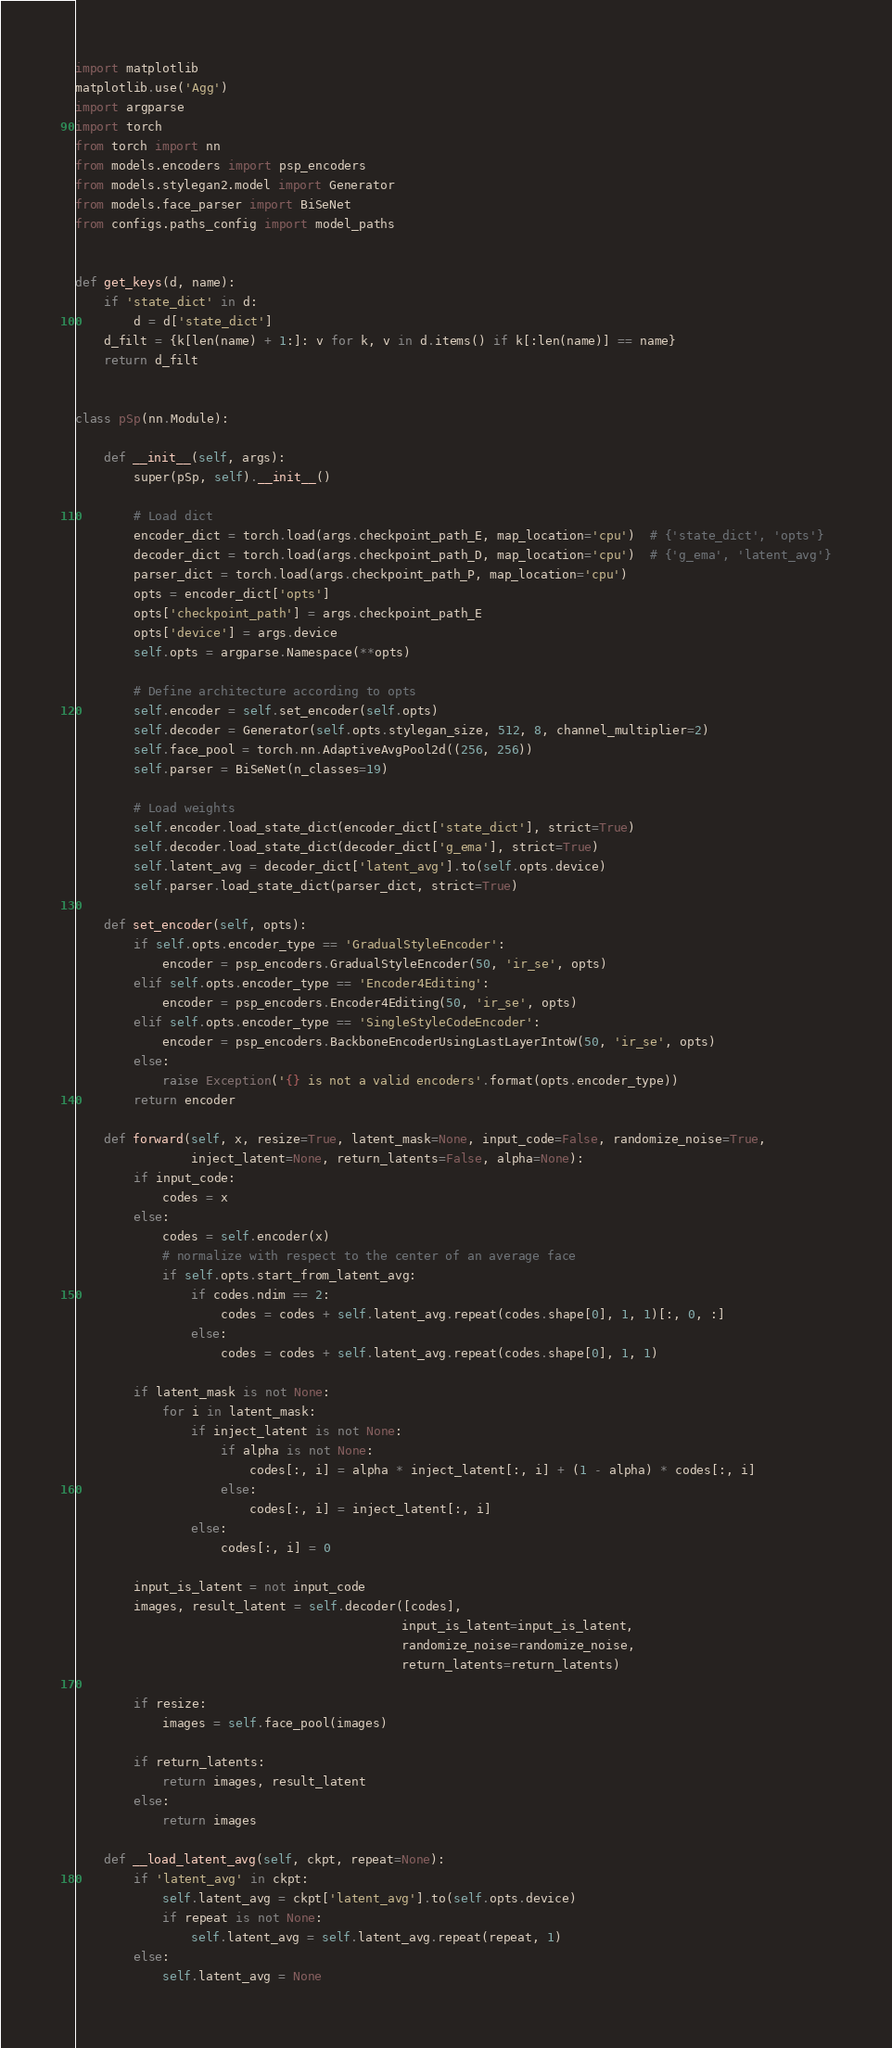<code> <loc_0><loc_0><loc_500><loc_500><_Python_>import matplotlib
matplotlib.use('Agg')
import argparse
import torch
from torch import nn
from models.encoders import psp_encoders
from models.stylegan2.model import Generator
from models.face_parser import BiSeNet
from configs.paths_config import model_paths


def get_keys(d, name):
    if 'state_dict' in d:
        d = d['state_dict']
    d_filt = {k[len(name) + 1:]: v for k, v in d.items() if k[:len(name)] == name}
    return d_filt


class pSp(nn.Module):

    def __init__(self, args):
        super(pSp, self).__init__()

        # Load dict
        encoder_dict = torch.load(args.checkpoint_path_E, map_location='cpu')  # {'state_dict', 'opts'}
        decoder_dict = torch.load(args.checkpoint_path_D, map_location='cpu')  # {'g_ema', 'latent_avg'}
        parser_dict = torch.load(args.checkpoint_path_P, map_location='cpu')
        opts = encoder_dict['opts']
        opts['checkpoint_path'] = args.checkpoint_path_E
        opts['device'] = args.device
        self.opts = argparse.Namespace(**opts)
        
        # Define architecture according to opts
        self.encoder = self.set_encoder(self.opts)
        self.decoder = Generator(self.opts.stylegan_size, 512, 8, channel_multiplier=2)
        self.face_pool = torch.nn.AdaptiveAvgPool2d((256, 256))
        self.parser = BiSeNet(n_classes=19)
        
        # Load weights
        self.encoder.load_state_dict(encoder_dict['state_dict'], strict=True)
        self.decoder.load_state_dict(decoder_dict['g_ema'], strict=True)
        self.latent_avg = decoder_dict['latent_avg'].to(self.opts.device)
        self.parser.load_state_dict(parser_dict, strict=True)

    def set_encoder(self, opts):
        if self.opts.encoder_type == 'GradualStyleEncoder':
            encoder = psp_encoders.GradualStyleEncoder(50, 'ir_se', opts)
        elif self.opts.encoder_type == 'Encoder4Editing':
            encoder = psp_encoders.Encoder4Editing(50, 'ir_se', opts)
        elif self.opts.encoder_type == 'SingleStyleCodeEncoder':
            encoder = psp_encoders.BackboneEncoderUsingLastLayerIntoW(50, 'ir_se', opts)
        else:
            raise Exception('{} is not a valid encoders'.format(opts.encoder_type))
        return encoder

    def forward(self, x, resize=True, latent_mask=None, input_code=False, randomize_noise=True,
                inject_latent=None, return_latents=False, alpha=None):
        if input_code:
            codes = x
        else:
            codes = self.encoder(x)
            # normalize with respect to the center of an average face
            if self.opts.start_from_latent_avg:
                if codes.ndim == 2:
                    codes = codes + self.latent_avg.repeat(codes.shape[0], 1, 1)[:, 0, :]
                else:
                    codes = codes + self.latent_avg.repeat(codes.shape[0], 1, 1)

        if latent_mask is not None:
            for i in latent_mask:
                if inject_latent is not None:
                    if alpha is not None:
                        codes[:, i] = alpha * inject_latent[:, i] + (1 - alpha) * codes[:, i]
                    else:
                        codes[:, i] = inject_latent[:, i]
                else:
                    codes[:, i] = 0

        input_is_latent = not input_code
        images, result_latent = self.decoder([codes],
                                             input_is_latent=input_is_latent,
                                             randomize_noise=randomize_noise,
                                             return_latents=return_latents)

        if resize:
            images = self.face_pool(images)

        if return_latents:
            return images, result_latent
        else:
            return images

    def __load_latent_avg(self, ckpt, repeat=None):
        if 'latent_avg' in ckpt:
            self.latent_avg = ckpt['latent_avg'].to(self.opts.device)
            if repeat is not None:
                self.latent_avg = self.latent_avg.repeat(repeat, 1)
        else:
            self.latent_avg = None
</code> 